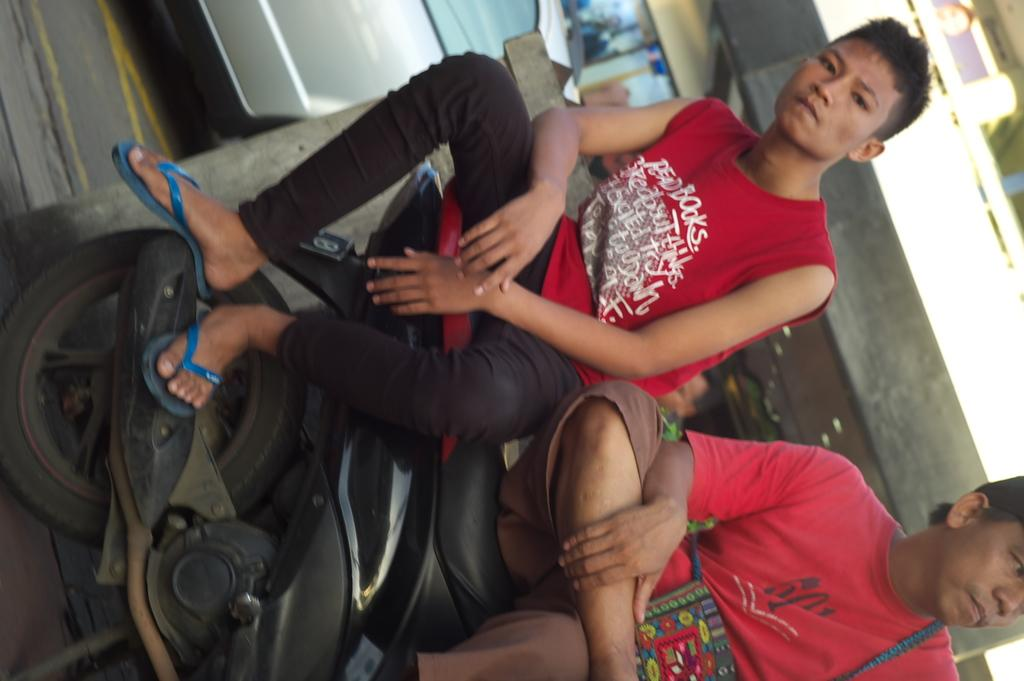How many people are in the image? There are two persons in the image. What are the two persons doing in the image? The two persons are sitting on a bike. What color are the dresses worn by the two persons? Both persons are wearing red color dresses. Is the bike stuck in quicksand in the image? No, there is no quicksand present in the image. Can you hear a bell ringing in the image? There is no bell present in the image, so it cannot be heard. 